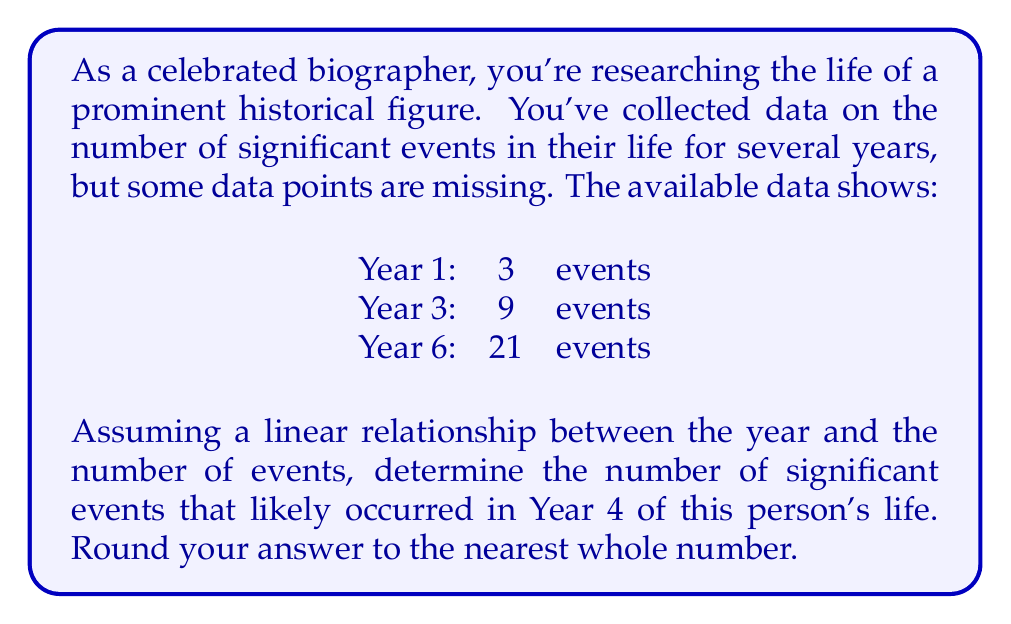Can you solve this math problem? To solve this problem, we need to use linear interpolation. Let's approach this step-by-step:

1) First, we need to find the slope of the line connecting these points. We can use the formula:

   $$ m = \frac{y_2 - y_1}{x_2 - x_1} $$

   where $(x_1, y_1)$ and $(x_2, y_2)$ are two known points.

2) Let's use Years 1 and 6:

   $$ m = \frac{21 - 3}{6 - 1} = \frac{18}{5} = 3.6 $$

3) Now that we have the slope, we can use the point-slope form of a line:

   $$ y - y_1 = m(x - x_1) $$

4) Let's use Year 1 as our known point $(x_1, y_1)$:

   $$ y - 3 = 3.6(x - 1) $$

5) To find the y-intercept, let's solve for y:

   $$ y = 3.6x - 3.6 + 3 = 3.6x - 0.6 $$

6) Now we have our linear equation:

   $$ y = 3.6x - 0.6 $$

7) To find the number of events in Year 4, we substitute x = 4:

   $$ y = 3.6(4) - 0.6 = 14.4 - 0.6 = 13.8 $$

8) Rounding to the nearest whole number:

   $$ 13.8 \approx 14 $$

Therefore, based on this linear interpolation, there were likely 14 significant events in Year 4 of this person's life.
Answer: 14 events 